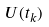Convert formula to latex. <formula><loc_0><loc_0><loc_500><loc_500>U ( t _ { k } )</formula> 